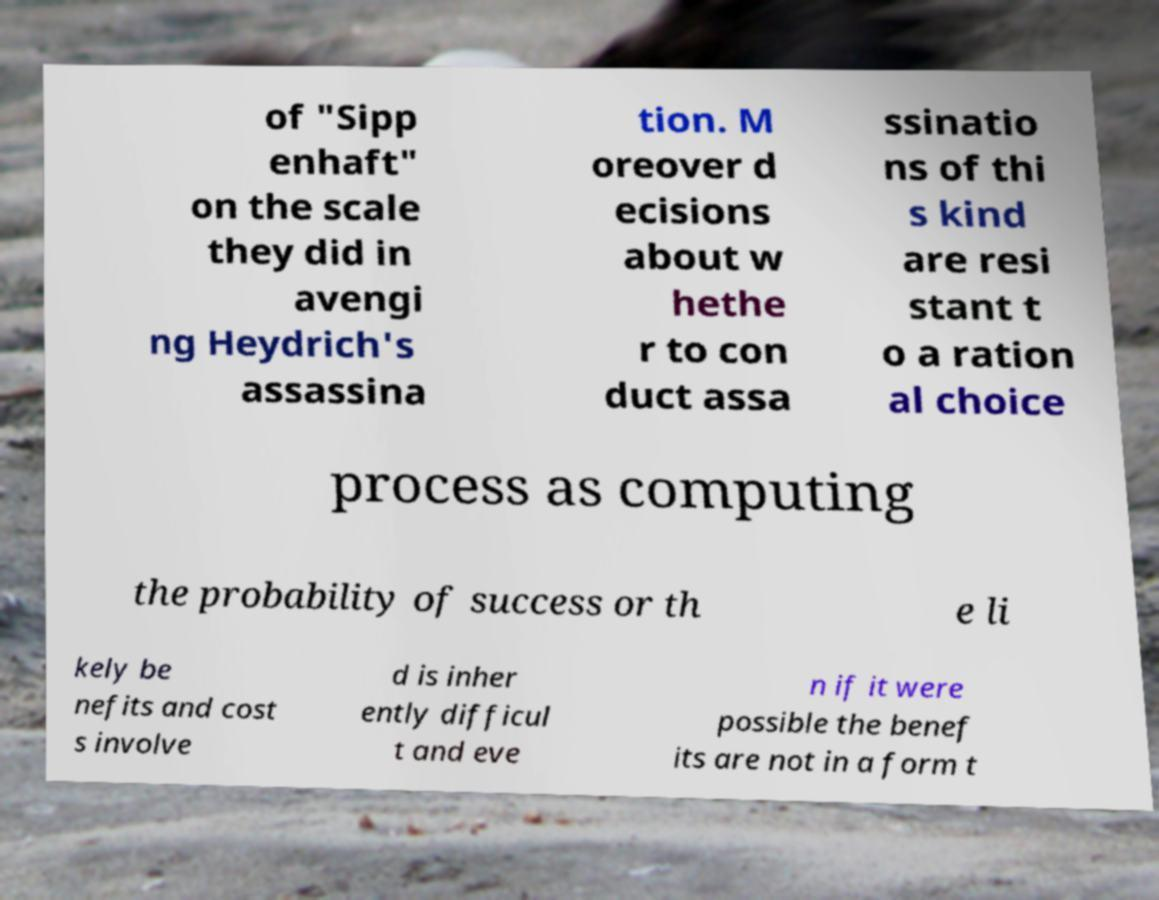Please read and relay the text visible in this image. What does it say? of "Sipp enhaft" on the scale they did in avengi ng Heydrich's assassina tion. M oreover d ecisions about w hethe r to con duct assa ssinatio ns of thi s kind are resi stant t o a ration al choice process as computing the probability of success or th e li kely be nefits and cost s involve d is inher ently difficul t and eve n if it were possible the benef its are not in a form t 